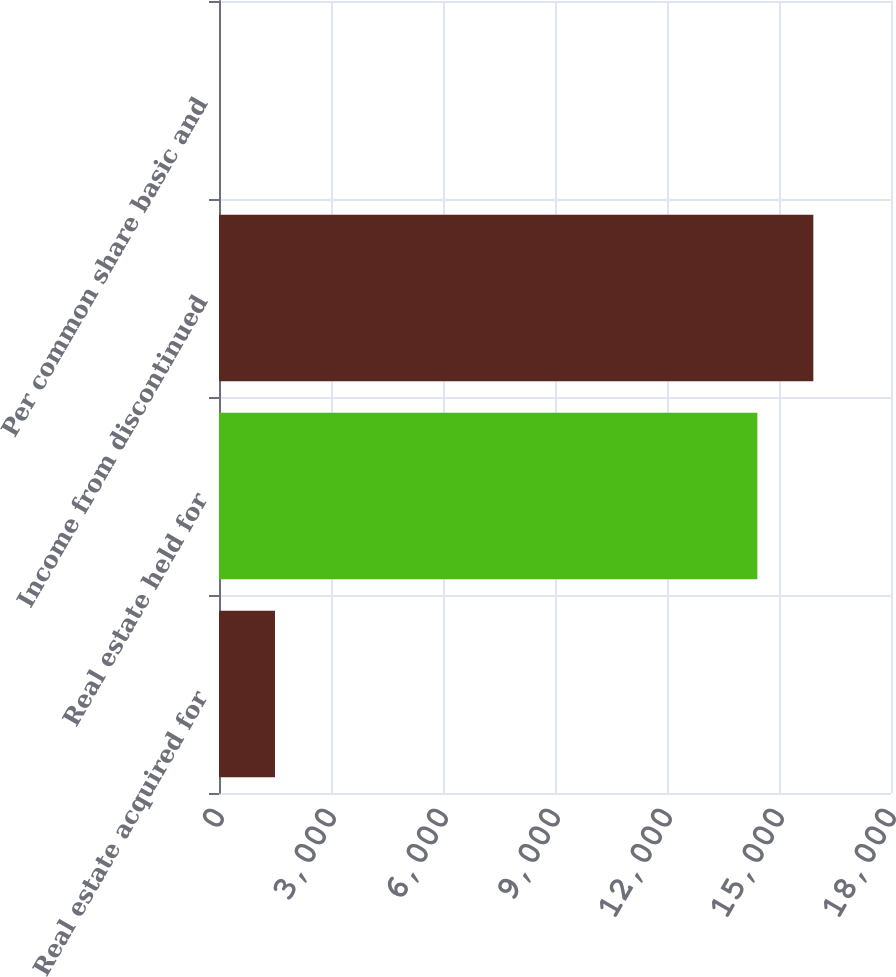<chart> <loc_0><loc_0><loc_500><loc_500><bar_chart><fcel>Real estate acquired for<fcel>Real estate held for<fcel>Income from discontinued<fcel>Per common share basic and<nl><fcel>1499.64<fcel>14420<fcel>15919.5<fcel>0.15<nl></chart> 